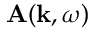<formula> <loc_0><loc_0><loc_500><loc_500>A ( k , \omega )</formula> 